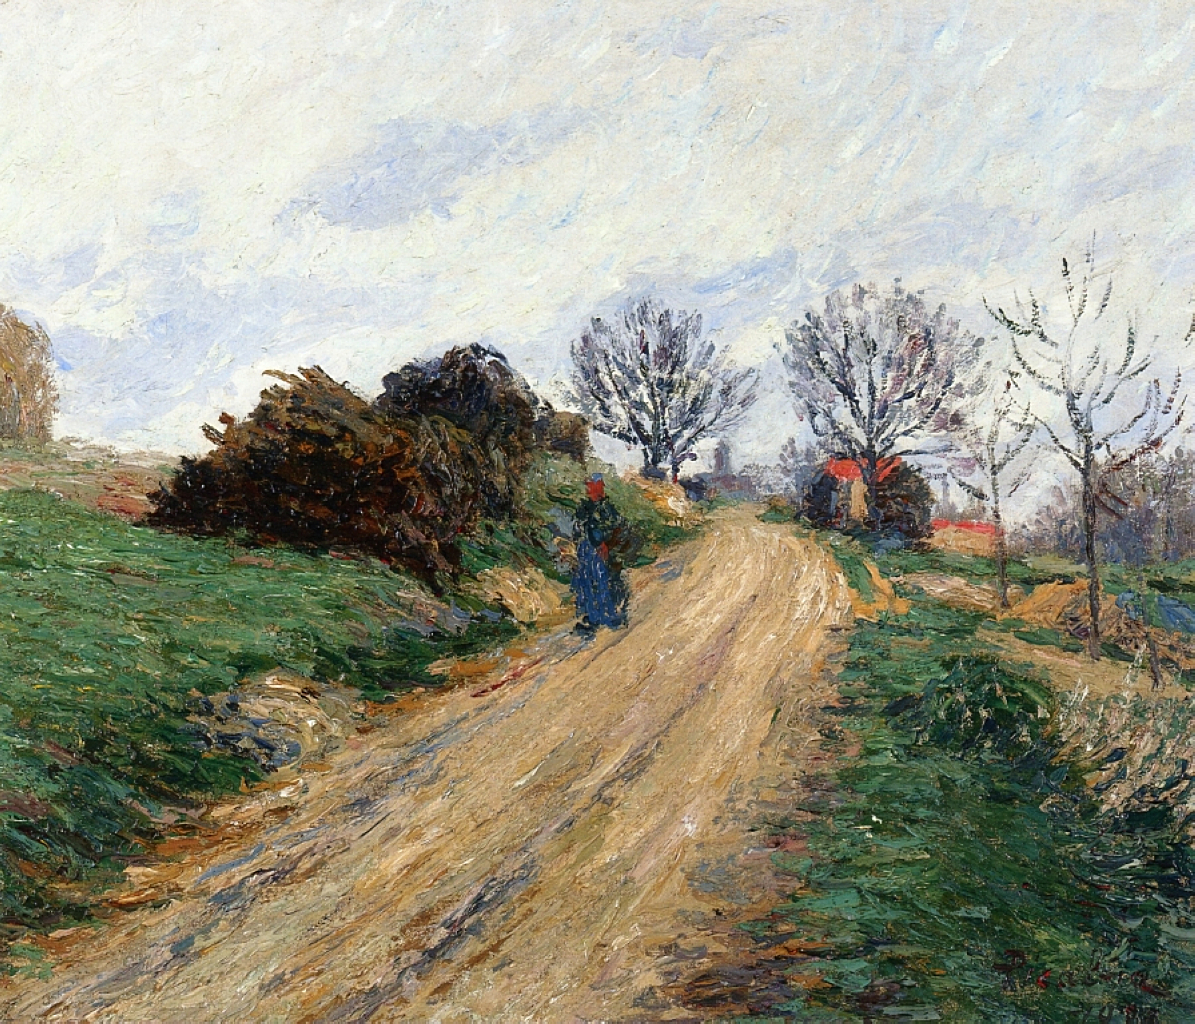What could be the historical context of this painting? The historical context of this painting could place it in the late 19th century, during the peak of the impressionist movement. During this period, artists sought to capture the essence of their surroundings with an emphasis on light and color rather than detailed realism. This movement was partly a reaction to the rigid structures of academic painting, favoring instead spontaneity and the artist's personal perception of the scene. Painted en plein air, the scene might reflect a shift towards appreciating the natural world and rural life, amidst the growing industrialization of Europe. Imagine you are standing in the scene depicted in the painting, what do you feel, and what sounds might you hear? Standing in the scene depicted in the painting, you would feel a profound sense of calm and relaxation. The tranquility of the countryside envelops you, with the gentle rustling of leaves and the distant chirping of birds creating a soothing soundscape. The faint crunch of dirt and gravel underfoot as you walk along the winding road adds to the immersive experience. A gentle breeze carries the refreshing scent of earth and greenery, further grounding you in the moment. It's a perfect escape from the hustle and bustle, inviting you to pause, breathe, and simply be present in nature. 